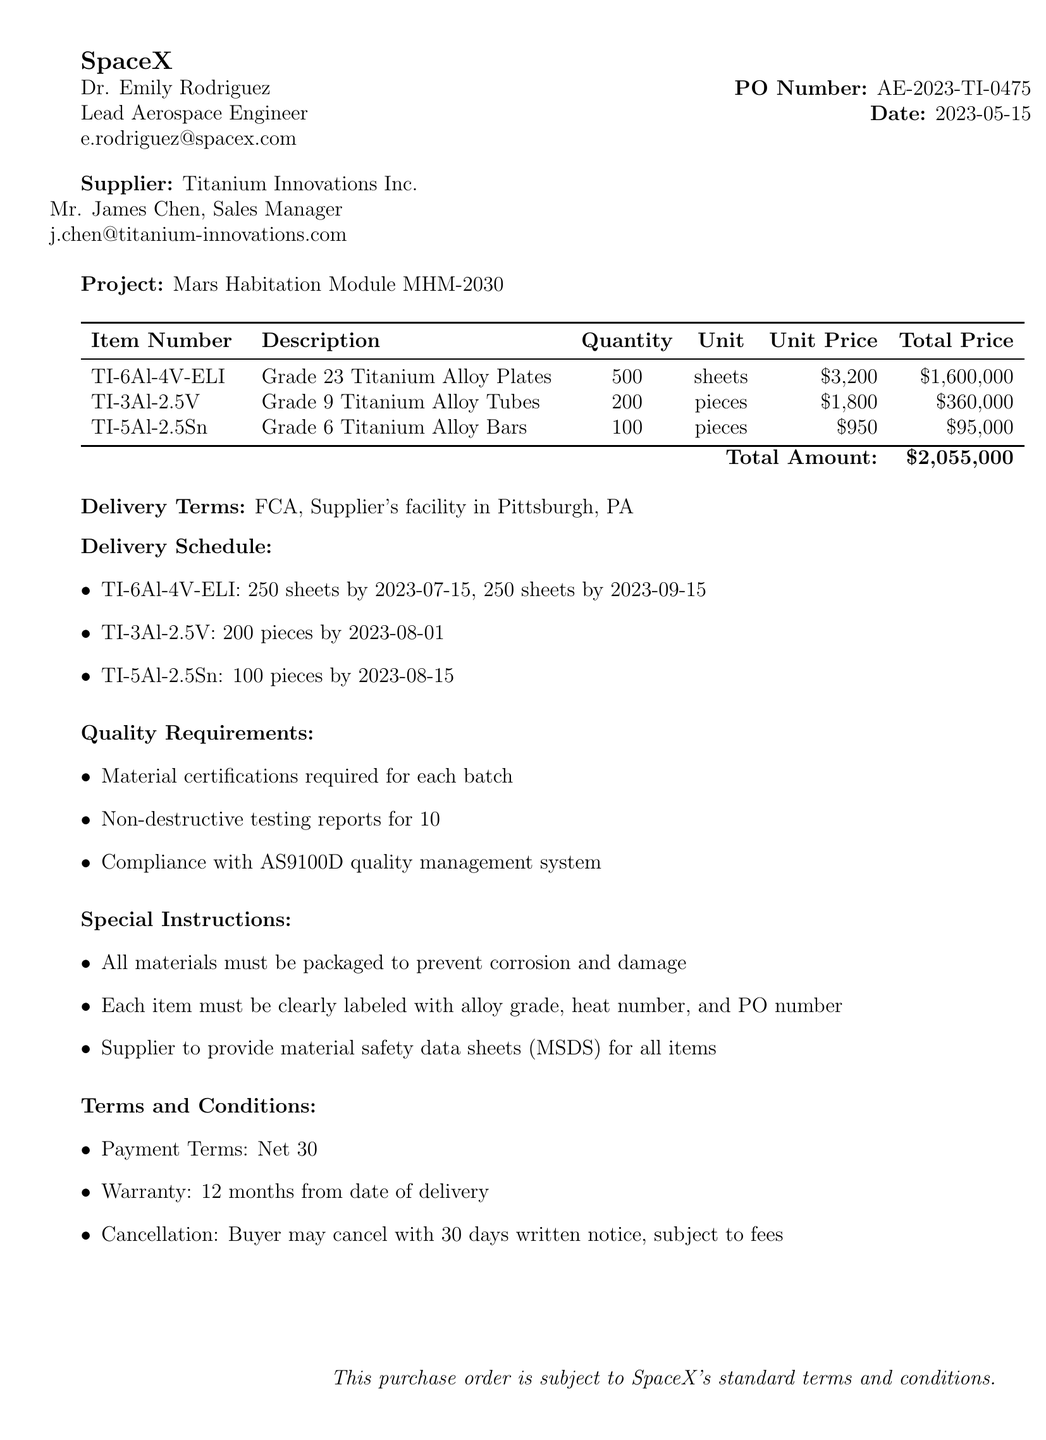What is the PO number? The purchase order number is specified in the document, which is AE-2023-TI-0475.
Answer: AE-2023-TI-0475 Who is the contact person at the buyer's side? The buyer's contact person mentioned in the document is Dr. Emily Rodriguez.
Answer: Dr. Emily Rodriguez What is the total amount of the purchase order? The total amount for the purchase order is explicitly stated in the document as $2,055,000.
Answer: $2,055,000 How many pieces of Grade 9 Titanium Alloy Tubes are ordered? The document lists the quantity of Grade 9 Titanium Alloy Tubes as 200 pieces.
Answer: 200 pieces What are the delivery dates for the first shipment of TI-6Al-4V-ELI? The document states that the first shipment of TI-6Al-4V-ELI is for 250 sheets by July 15, 2023.
Answer: 250 sheets by July 15, 2023 What are the quality requirements listed for the components? The document specifies several quality requirements, including material certifications and non-destructive testing reports.
Answer: Material certifications required for each batch, Non-destructive testing reports for 10% of each item, Compliance with AS9100D quality management system What is the warranty period for the components? The warranty period as stated in the terms and conditions of the document is for 12 months from the date of delivery.
Answer: 12 months Where is the supplier's facility located? The document mentions that the supplier's facility is located in Pittsburgh, PA.
Answer: Pittsburgh, PA What payment terms are specified in the document? The document specifies that the payment terms are net 30 days.
Answer: Net 30 